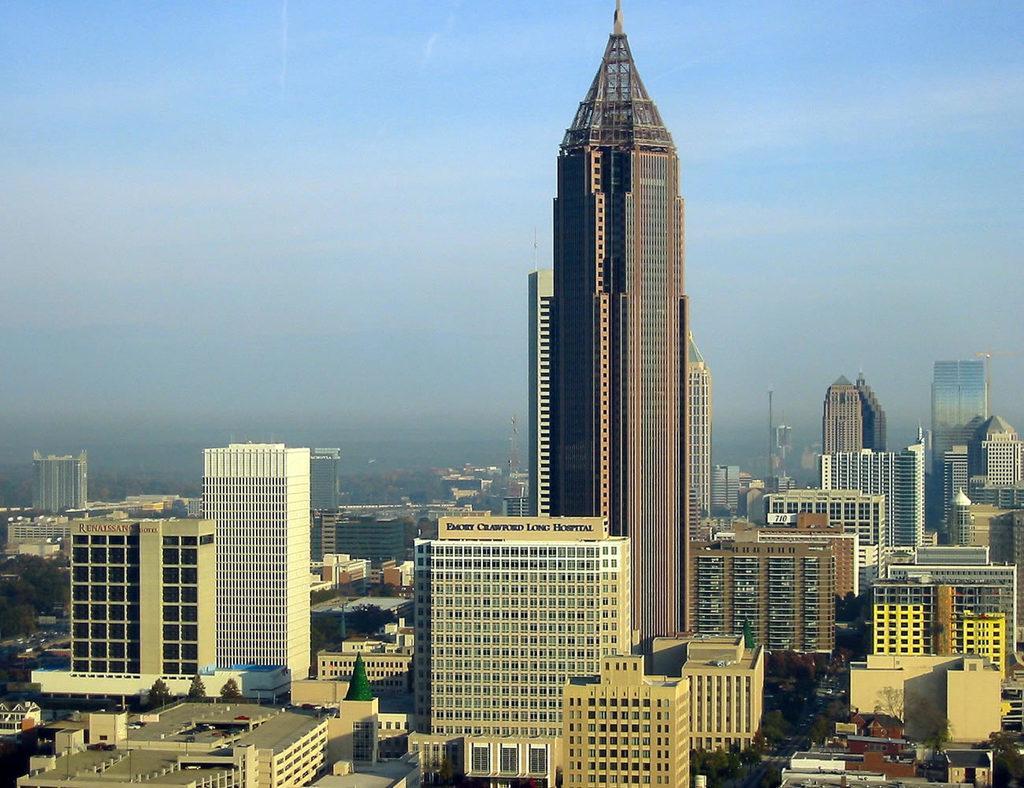Please provide a concise description of this image. In this image at the bottom there are some buildings and skyscrapers and some trees, in the background there are some mountains. On the top of the image there is sky. 